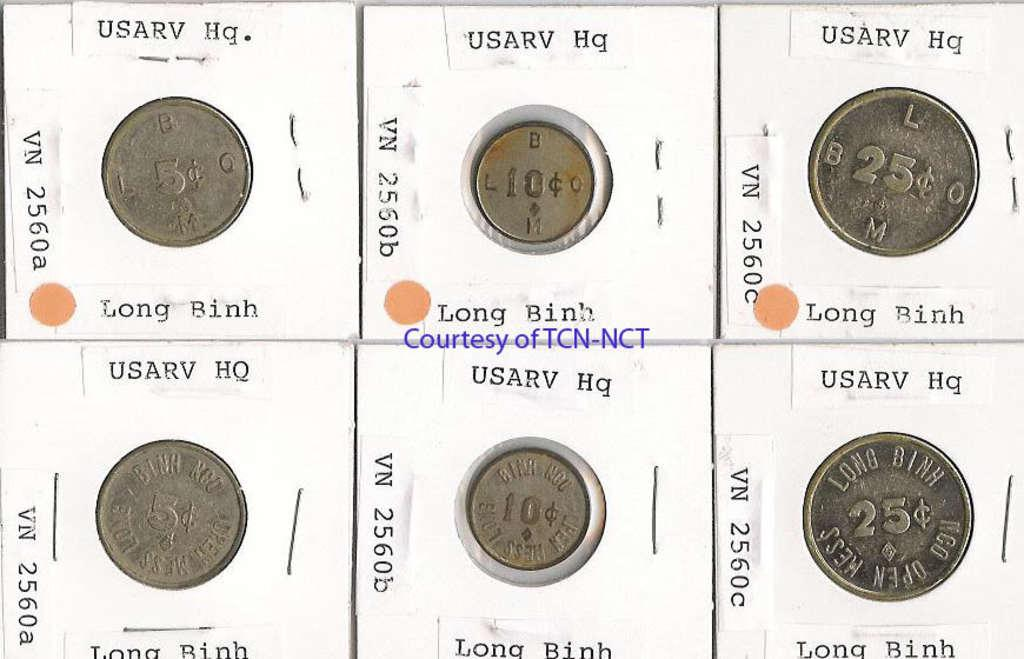<image>
Give a short and clear explanation of the subsequent image. Six coins are packaged and the middle of the grouping says courtesy of TCN NCT. 